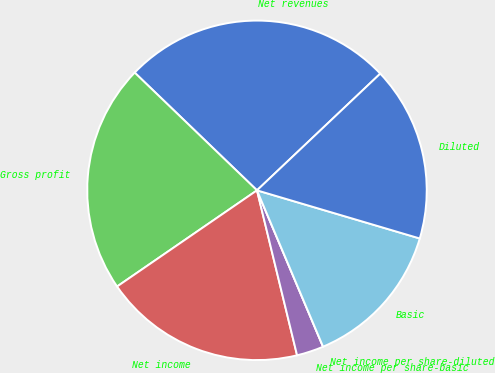Convert chart to OTSL. <chart><loc_0><loc_0><loc_500><loc_500><pie_chart><fcel>Net revenues<fcel>Gross profit<fcel>Net income<fcel>Net income per share-basic<fcel>Net income per share-diluted<fcel>Basic<fcel>Diluted<nl><fcel>25.74%<fcel>21.78%<fcel>19.21%<fcel>2.57%<fcel>0.0%<fcel>14.06%<fcel>16.64%<nl></chart> 